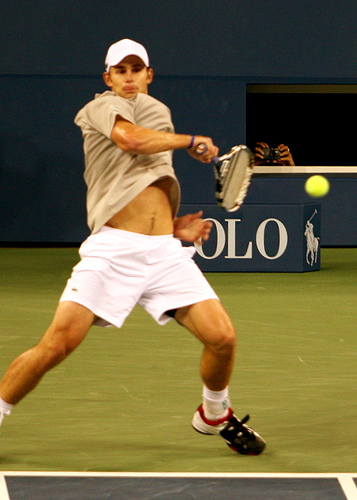<image>What is the name of the tennis player? I am not sure of the name of the tennis player. It could be George, Andre Agassi, Pete, Agassi, Polo, or Bob. What is the name of the tennis player? I don't know the name of the tennis player. It could be George, Andre Agassi, Pete, Agassi, Polo, or Bob. 